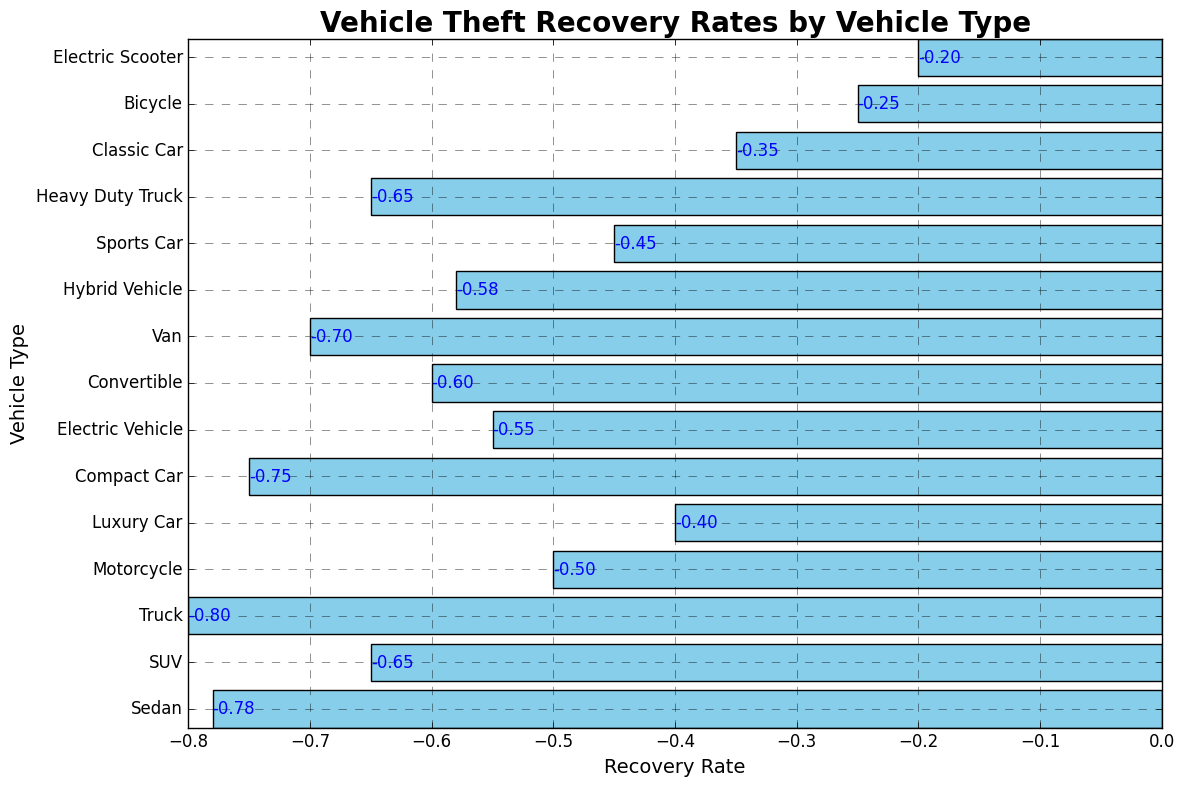what is the recovery rate for Electric Scooter? The bar labeled "Electric Scooter" indicates a recovery rate of -0.20.
Answer: -0.20 Which vehicle type has the lowest recovery rate? By comparing the bar lengths, the "Truck" has the most negative recovery rate of -0.80.
Answer: Truck How much higher is the recovery rate for SUVs compared to Luxury Cars? The recovery rate for SUVs is -0.65 and for Luxury Cars is -0.40. The difference is -0.40 - (-0.65) = 0.25.
Answer: 0.25 What is the average recovery rate for all vehicle types? Sum all recovery rates: -0.78 + (-0.65) + (-0.80) + (-0.50) + (-0.40) + (-0.75) + (-0.55) + (-0.60) + (-0.70) + (-0.58) + (-0.45) + (-0.65) + (-0.35) + (-0.25) + (-0.20) = -8.21. Divide by the number of vehicle types (15): -8.21 / 15 ≈ -0.55.
Answer: -0.55 Which vehicle types have a recovery rate greater than -0.60? The vehicle types "Luxury Car" (-0.40), "Sports Car" (-0.45), "Motorcycle" (-0.50), "Electric Vehicle" (-0.55), "Hybrid Vehicle" (-0.58), "Classic Car" (-0.35), "Bicycle" (-0.25), and "Electric Scooter" (-0.20) have recovery rates greater than -0.60.
Answer: Luxury Car, Sports Car, Motorcycle, Electric Vehicle, Hybrid Vehicle, Classic Car, Bicycle, Electric Scooter What is the recovery rate difference between Sedan and Compact Car? The recovery rate for the Sedan is -0.78, and for the Compact Car it is -0.75. The difference is -0.78 - (-0.75) = -0.03.
Answer: -0.03 How does the recovery rate of SUVs compare to Heavy Duty Trucks? The recovery rate for SUVs is -0.65, and for Heavy Duty Trucks it is also -0.65. They are equal.
Answer: Equal What visual attribute enables identifying the least negative recovery rate? The shortest bar on the left (least negative) represents "Electric Scooter" with a recovery rate of -0.20.
Answer: Shortest bar on the left Which vehicle type has a similar recovery rate to an Electric Vehicle? Both the Electric Vehicle and Hybrid Vehicle have close recovery rates, with -0.55 and -0.58 respectively.
Answer: Hybrid Vehicle 